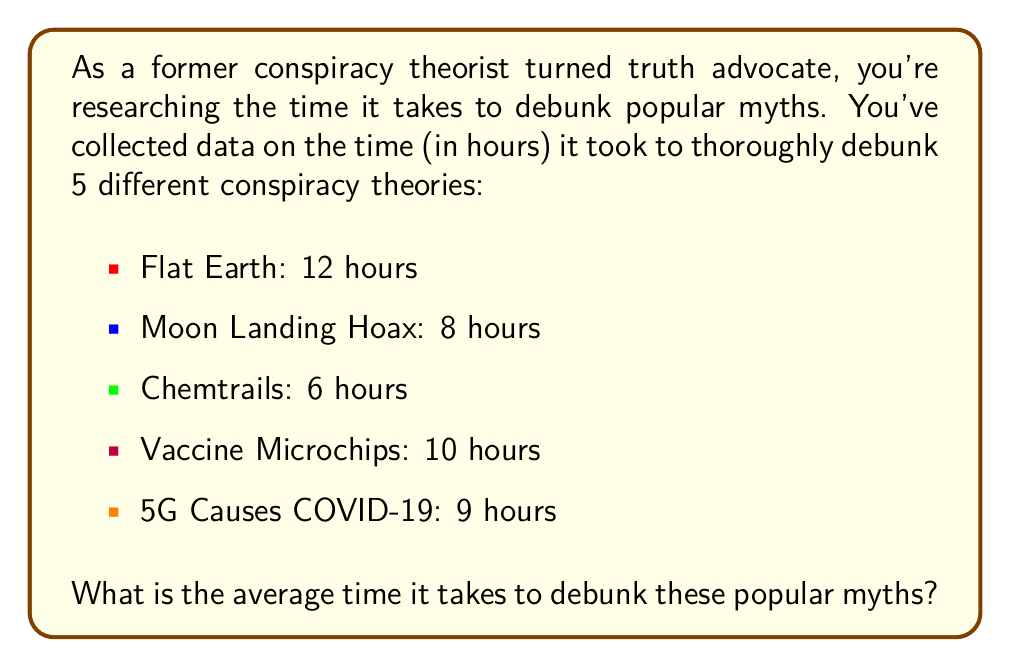Help me with this question. To find the average time it takes to debunk these popular myths, we need to:

1. Sum up all the times
2. Divide the sum by the number of myths

Let's go through this step-by-step:

1. Sum up all the times:
   $12 + 8 + 6 + 10 + 9 = 45$ hours

2. Count the number of myths:
   There are 5 myths in total.

3. Calculate the average:
   Average = Sum of times ÷ Number of myths
   $$ \text{Average} = \frac{45 \text{ hours}}{5} = 9 \text{ hours} $$

Therefore, the average time it takes to debunk these popular myths is 9 hours.
Answer: $9$ hours 